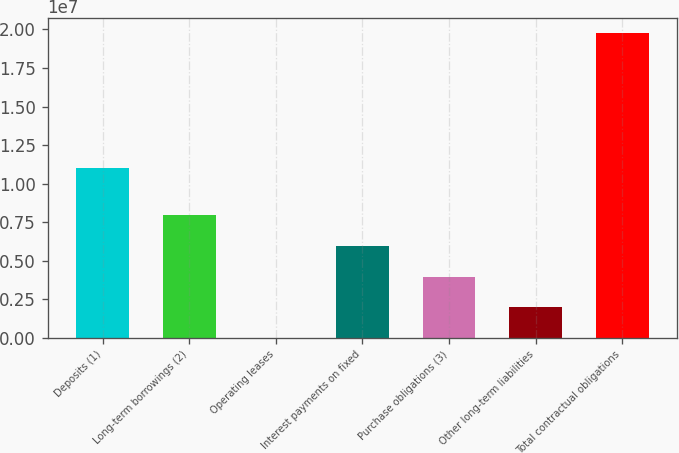<chart> <loc_0><loc_0><loc_500><loc_500><bar_chart><fcel>Deposits (1)<fcel>Long-term borrowings (2)<fcel>Operating leases<fcel>Interest payments on fixed<fcel>Purchase obligations (3)<fcel>Other long-term liabilities<fcel>Total contractual obligations<nl><fcel>1.10469e+07<fcel>7.99759e+06<fcel>11216<fcel>5.93911e+06<fcel>3.96314e+06<fcel>1.98718e+06<fcel>1.97709e+07<nl></chart> 